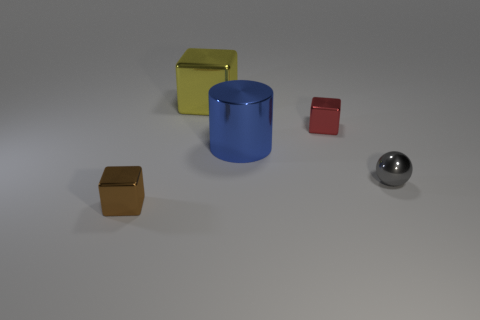The large shiny thing behind the large metal thing in front of the metal thing that is behind the small red object is what shape?
Offer a terse response. Cube. Is the brown thing the same size as the blue shiny object?
Make the answer very short. No. What number of other things are there of the same material as the tiny brown thing
Provide a succinct answer. 4. Is the shape of the big yellow object the same as the small red object?
Your response must be concise. Yes. How big is the yellow metallic thing that is left of the large metal cylinder?
Offer a terse response. Large. Do the metallic sphere and the cube left of the big metallic block have the same size?
Give a very brief answer. Yes. Are there fewer small brown blocks that are behind the big yellow thing than purple shiny cylinders?
Ensure brevity in your answer.  No. There is a large yellow object that is the same shape as the small brown object; what is it made of?
Provide a succinct answer. Metal. There is a object that is both behind the big blue cylinder and on the right side of the big yellow metal block; what is its shape?
Keep it short and to the point. Cube. The small gray thing that is the same material as the big yellow block is what shape?
Give a very brief answer. Sphere. 